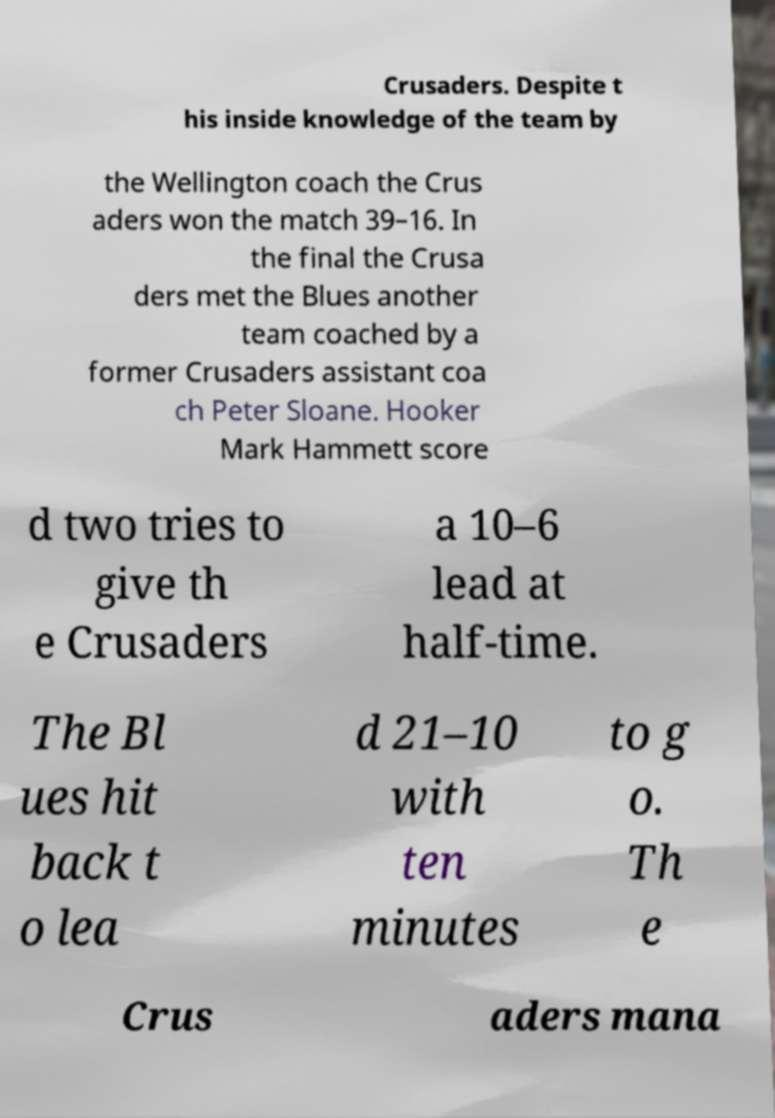Can you read and provide the text displayed in the image?This photo seems to have some interesting text. Can you extract and type it out for me? Crusaders. Despite t his inside knowledge of the team by the Wellington coach the Crus aders won the match 39–16. In the final the Crusa ders met the Blues another team coached by a former Crusaders assistant coa ch Peter Sloane. Hooker Mark Hammett score d two tries to give th e Crusaders a 10–6 lead at half-time. The Bl ues hit back t o lea d 21–10 with ten minutes to g o. Th e Crus aders mana 